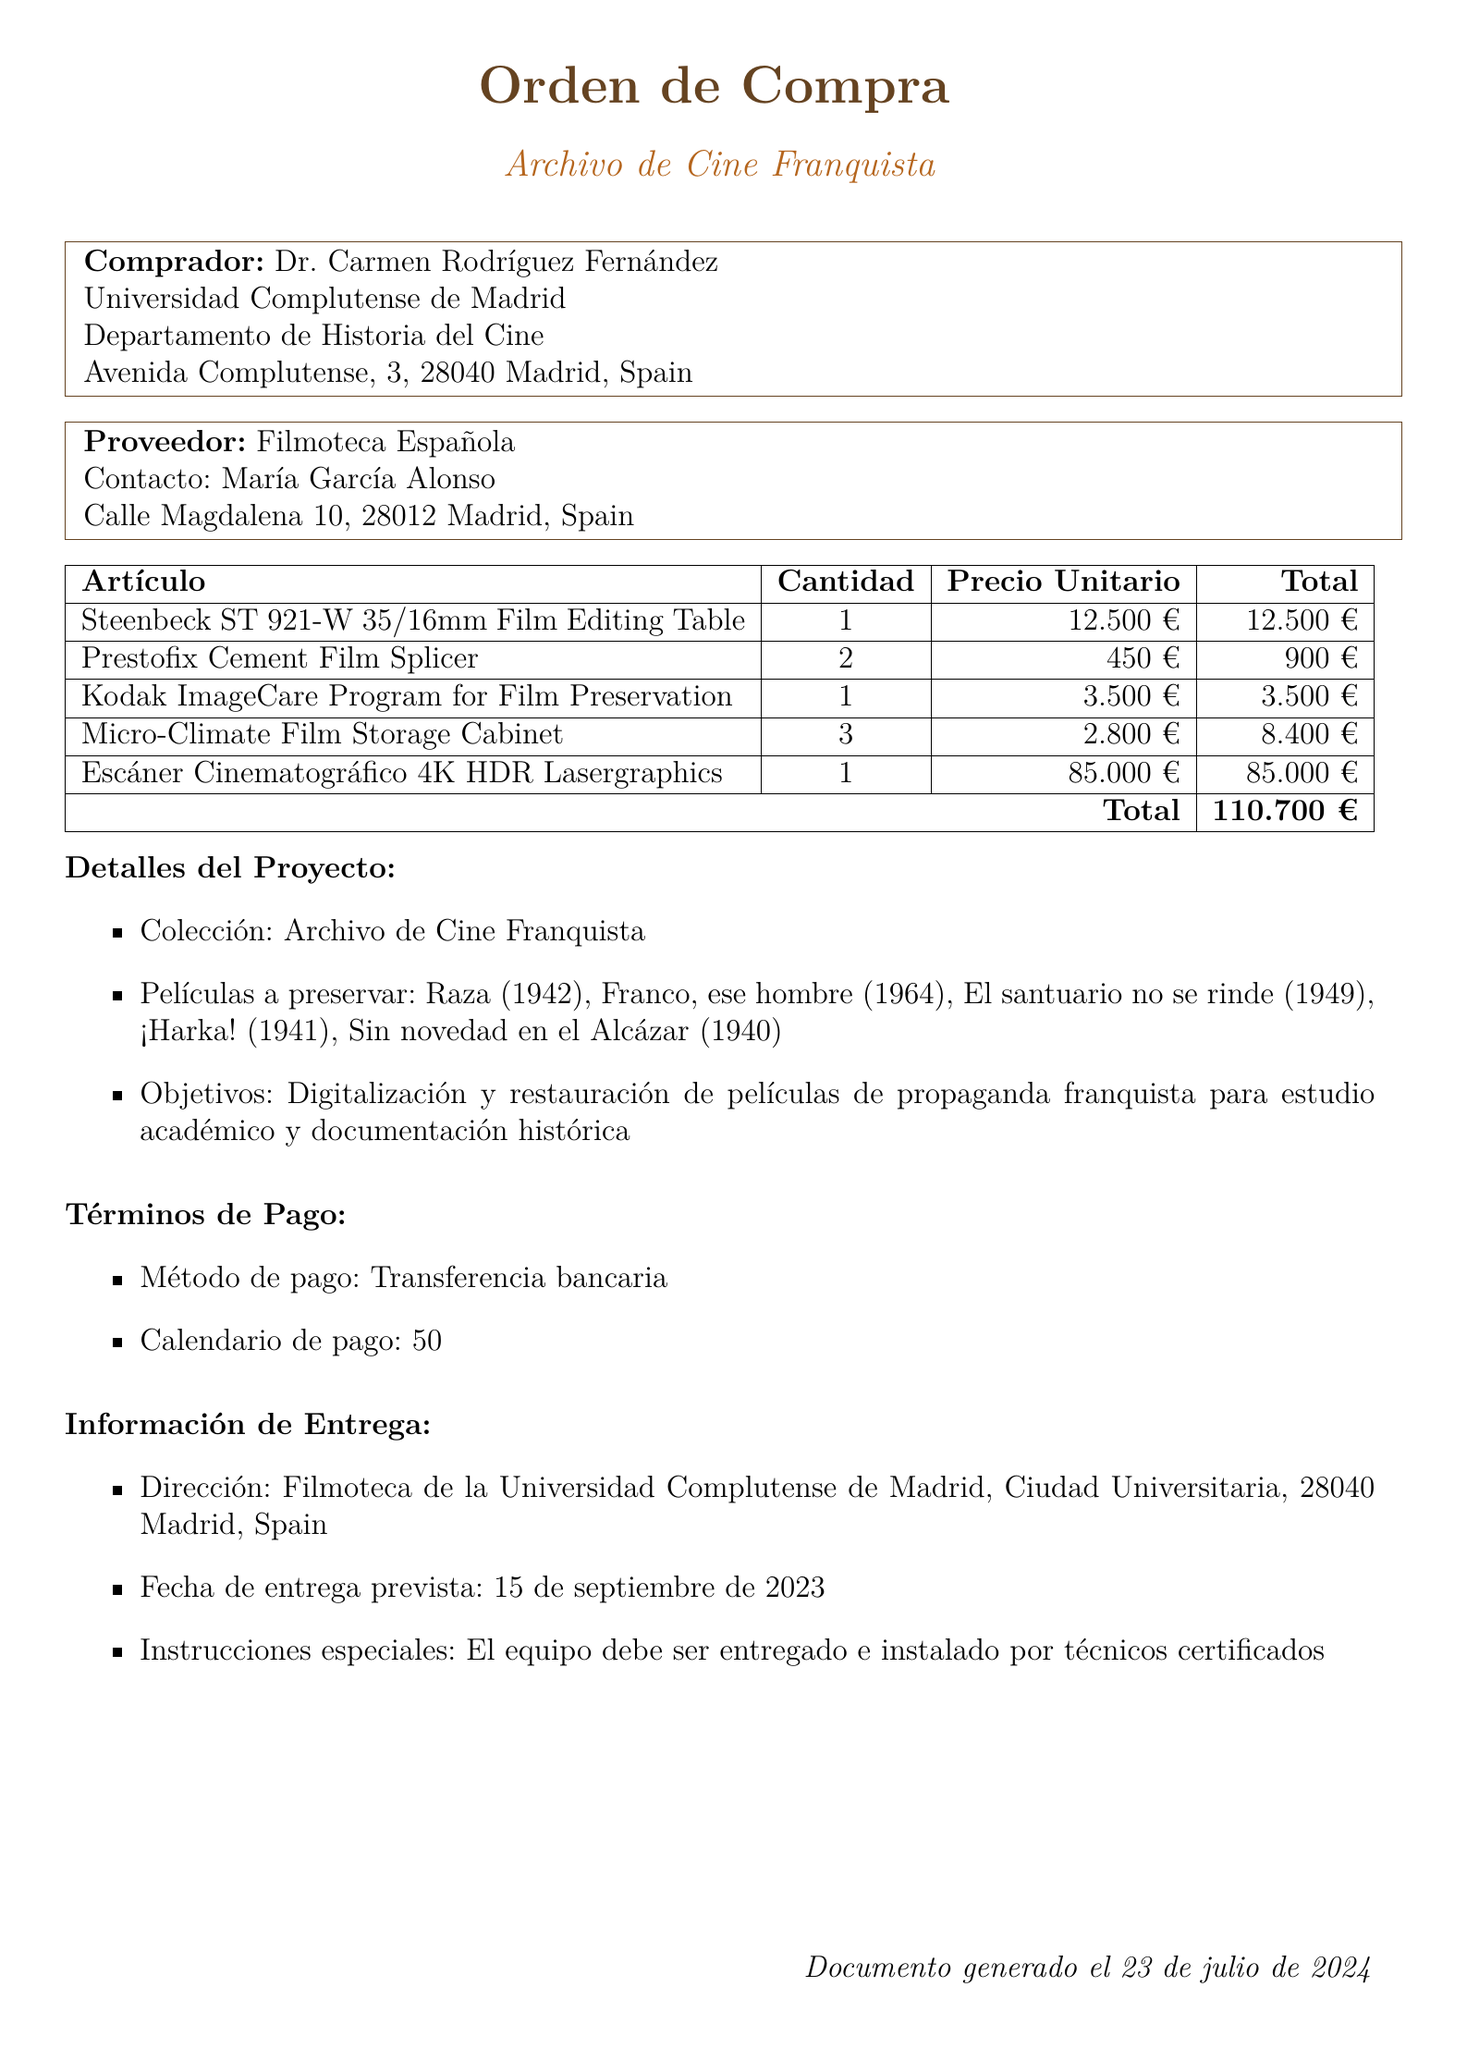What is the name of the purchaser? The purchaser's name is stated clearly in the document as Dr. Carmen Rodríguez Fernández.
Answer: Dr. Carmen Rodríguez Fernández How many Steenbeck editing tables were ordered? The quantity of Steenbeck editing tables can be found in the equipment section, which specifies 1 unit.
Answer: 1 What is the total amount for the order? The total amount is provided at the end of the document, summarizing all equipment costs, which totals to 110700 EUR.
Answer: 110700 EUR What is the expected delivery date of the equipment? The expected delivery date is explicitly mentioned in the delivery information as 2023-09-15.
Answer: 2023-09-15 Which institution is associated with the purchaser? The purchaser's associated institution is outlined in the document, specifying Universidad Complutense de Madrid.
Answer: Universidad Complutense de Madrid What special instructions are given for delivery? The special instructions for delivery can be found in the delivery information section, which states that the equipment must be delivered and installed by certified technicians.
Answer: Equipment must be delivered and installed by certified technicians How many Micro-Climate Film Storage Cabinets were ordered? The document lists the quantity of Micro-Climate Film Storage Cabinets, which is 3.
Answer: 3 What is the preservation goal mentioned in the project details? The preservation goal is outlined in the project details as "Digitization and restoration of Francoist propaganda films for academic study and historical documentation."
Answer: Digitization and restoration of Francoist propaganda films for academic study and historical documentation 